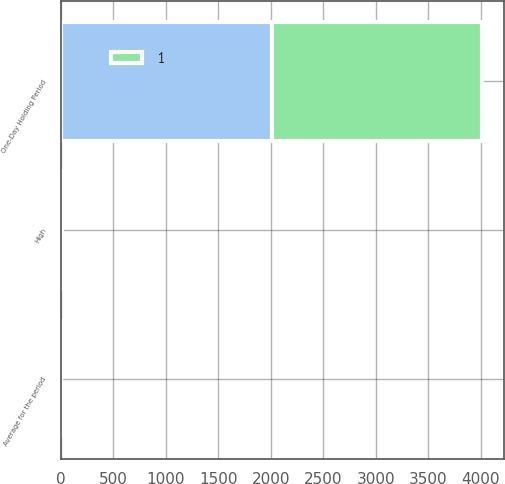Convert chart to OTSL. <chart><loc_0><loc_0><loc_500><loc_500><stacked_bar_chart><ecel><fcel>One-Day Holding Period<fcel>Average for the period<fcel>High<nl><fcel>nan<fcel>2008<fcel>2<fcel>3<nl><fcel>1<fcel>2007<fcel>3<fcel>7<nl></chart> 